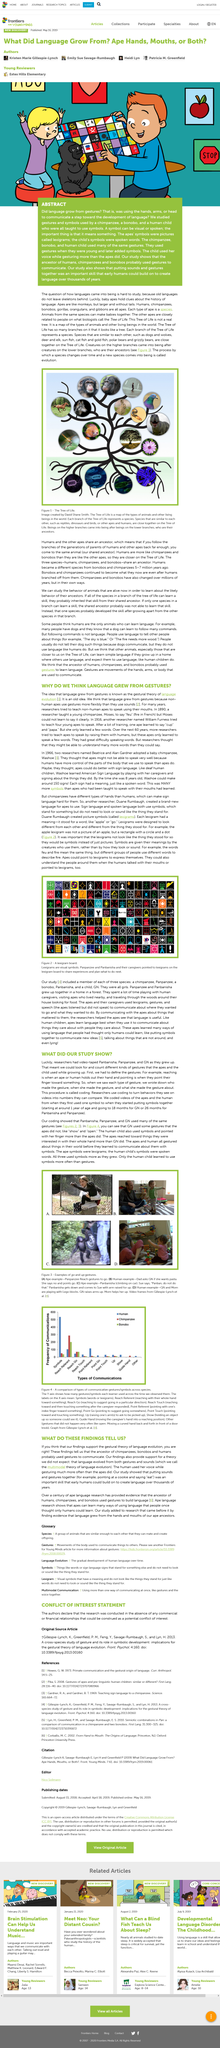Outline some significant characteristics in this image. The above picture portrays the use of both go and up gestures in both apes and humans, which are common forms of nonverbal communication. The researchers were able to observe and count different types of gestures used by the apes and the child while growing up because they had access to video footage of Panbanisha, Panpanzee, and GN throughout their development. The reason that sign language is difficult for chimpanzees is because they have different types of hands than humans. The gestural theory of language evolution posits that language emerged from gestures used for communication. The human child used symbols and pointed with her finger more than apes did. 